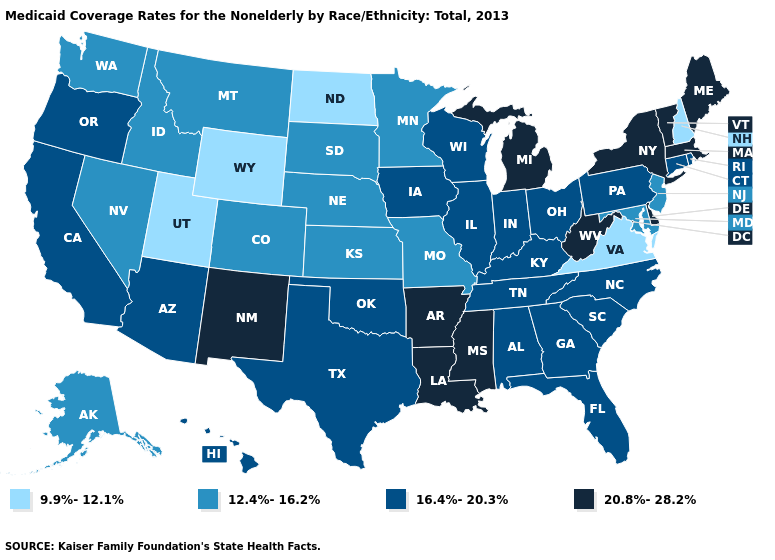Which states have the highest value in the USA?
Short answer required. Arkansas, Delaware, Louisiana, Maine, Massachusetts, Michigan, Mississippi, New Mexico, New York, Vermont, West Virginia. What is the lowest value in the West?
Concise answer only. 9.9%-12.1%. What is the value of North Carolina?
Write a very short answer. 16.4%-20.3%. Name the states that have a value in the range 16.4%-20.3%?
Give a very brief answer. Alabama, Arizona, California, Connecticut, Florida, Georgia, Hawaii, Illinois, Indiana, Iowa, Kentucky, North Carolina, Ohio, Oklahoma, Oregon, Pennsylvania, Rhode Island, South Carolina, Tennessee, Texas, Wisconsin. Which states have the lowest value in the USA?
Answer briefly. New Hampshire, North Dakota, Utah, Virginia, Wyoming. Name the states that have a value in the range 12.4%-16.2%?
Quick response, please. Alaska, Colorado, Idaho, Kansas, Maryland, Minnesota, Missouri, Montana, Nebraska, Nevada, New Jersey, South Dakota, Washington. Does Wisconsin have a higher value than Nebraska?
Write a very short answer. Yes. What is the value of Florida?
Be succinct. 16.4%-20.3%. How many symbols are there in the legend?
Quick response, please. 4. What is the lowest value in the MidWest?
Give a very brief answer. 9.9%-12.1%. What is the value of Missouri?
Quick response, please. 12.4%-16.2%. Name the states that have a value in the range 20.8%-28.2%?
Quick response, please. Arkansas, Delaware, Louisiana, Maine, Massachusetts, Michigan, Mississippi, New Mexico, New York, Vermont, West Virginia. What is the value of Pennsylvania?
Quick response, please. 16.4%-20.3%. What is the value of Rhode Island?
Give a very brief answer. 16.4%-20.3%. What is the value of North Dakota?
Quick response, please. 9.9%-12.1%. 